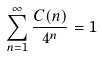Convert formula to latex. <formula><loc_0><loc_0><loc_500><loc_500>\sum _ { n = 1 } ^ { \infty } \frac { C ( n ) } { 4 ^ { n } } = 1</formula> 